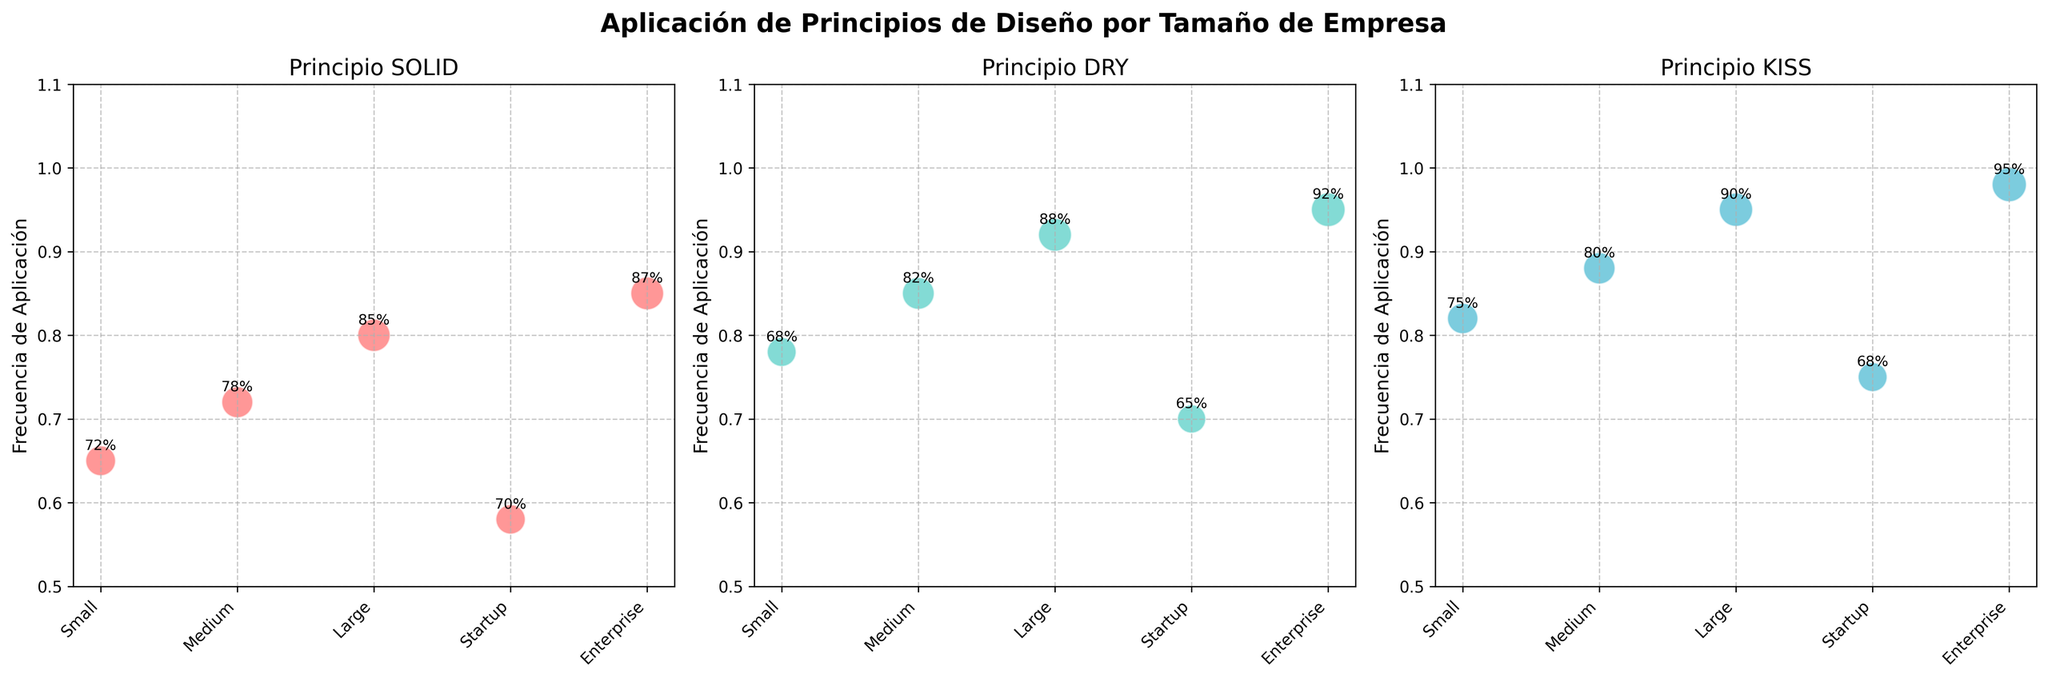What's the title of the chart? The title of the chart is located at the top center and reads 'Aplicación de Principios de Diseño por Tamaño de Empresa'.
Answer: 'Aplicación de Principios de Diseño por Tamaño de Empresa' Which company size applied the SOLID principle most frequently? For the SOLID principle, the largest frequency is found by locating the highest y-value in the subplot for SOLID, which is 0.85 for Enterprise companies.
Answer: Enterprise What is the employee satisfaction percentage for Medium companies applying the DRY principle? Find the DRY principle subplot and locate the Employee Satisfaction for Medium companies, which is annotated next to the corresponding bubble and equal to 82%.
Answer: 82% Are employee satisfaction scores generally higher for larger company sizes when applying the KISS principle? By examining the KISS principle subplot, we see that as the company size increases (from Startup to Enterprise), the employee satisfaction scores also increase (68%, 75%, 80%, 90%, 95%). This shows a rising trend.
Answer: Yes How does the frequency of applying the KISS principle compare between Small and Startup companies? From the KISS principle subplot, the frequencies for Small and Startup companies are 0.82 and 0.75, respectively. Small companies apply the KISS principle more frequently than Startups.
Answer: Small companies Which design principle has the highest frequency of application across all company sizes? Compare the highest frequencies from all three subplots: 
SOLID highest is 0.85 (Enterprise), 
DRY highest is 0.95 (Enterprise), 
KISS highest is 0.98 (Enterprise). 
Hence, the KISS principle has the highest frequency of application.
Answer: KISS What is the average frequency of applying the SOLID principle across all company sizes? The frequencies for SOLID are: 0.65, 0.72, 0.80, 0.58, 0.85. Summing these: 0.65 + 0.72 + 0.80 + 0.58 + 0.85 = 3.60. Dividing by 5 (number of data points) gives 3.60 / 5 = 0.72.
Answer: 0.72 